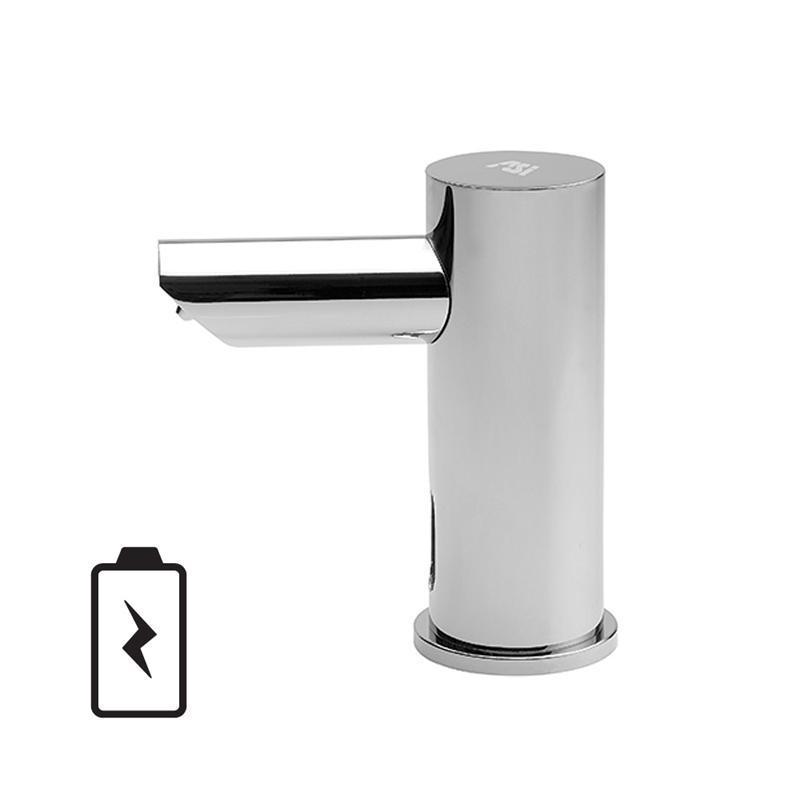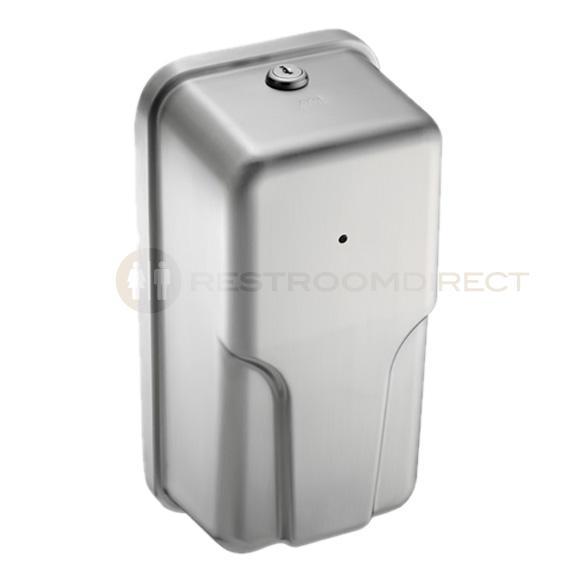The first image is the image on the left, the second image is the image on the right. Given the left and right images, does the statement "In one of the images, there is a manual soap dispenser with a nozzle facing left." hold true? Answer yes or no. No. 